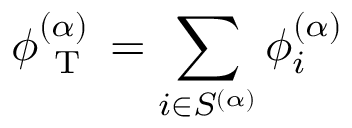Convert formula to latex. <formula><loc_0><loc_0><loc_500><loc_500>{ \phi _ { T } ^ { ( \alpha ) } = \sum _ { i \in S ^ { ( \alpha ) } } \phi _ { i } ^ { ( \alpha ) } }</formula> 